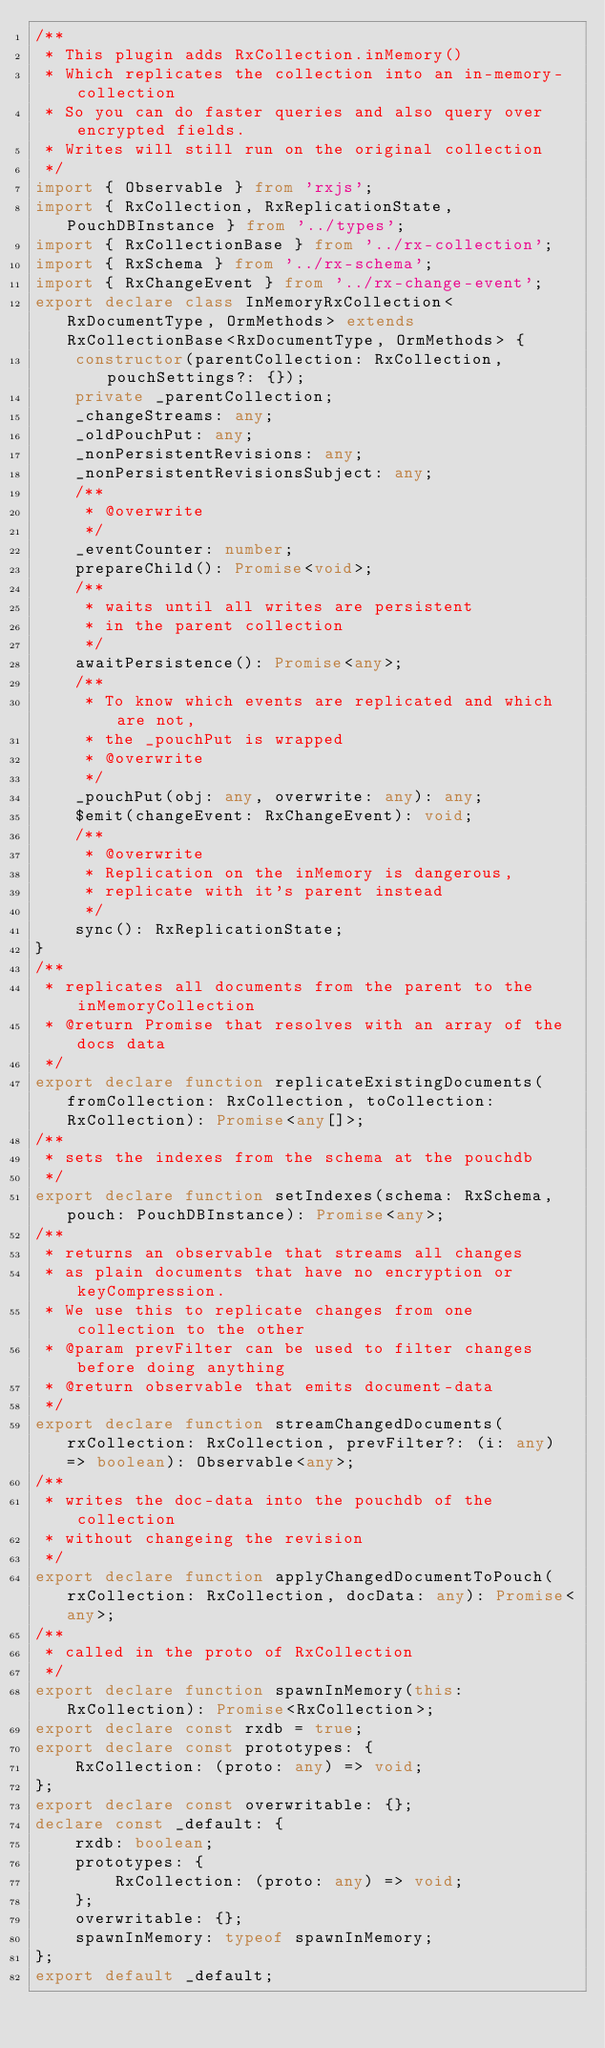Convert code to text. <code><loc_0><loc_0><loc_500><loc_500><_TypeScript_>/**
 * This plugin adds RxCollection.inMemory()
 * Which replicates the collection into an in-memory-collection
 * So you can do faster queries and also query over encrypted fields.
 * Writes will still run on the original collection
 */
import { Observable } from 'rxjs';
import { RxCollection, RxReplicationState, PouchDBInstance } from '../types';
import { RxCollectionBase } from '../rx-collection';
import { RxSchema } from '../rx-schema';
import { RxChangeEvent } from '../rx-change-event';
export declare class InMemoryRxCollection<RxDocumentType, OrmMethods> extends RxCollectionBase<RxDocumentType, OrmMethods> {
    constructor(parentCollection: RxCollection, pouchSettings?: {});
    private _parentCollection;
    _changeStreams: any;
    _oldPouchPut: any;
    _nonPersistentRevisions: any;
    _nonPersistentRevisionsSubject: any;
    /**
     * @overwrite
     */
    _eventCounter: number;
    prepareChild(): Promise<void>;
    /**
     * waits until all writes are persistent
     * in the parent collection
     */
    awaitPersistence(): Promise<any>;
    /**
     * To know which events are replicated and which are not,
     * the _pouchPut is wrapped
     * @overwrite
     */
    _pouchPut(obj: any, overwrite: any): any;
    $emit(changeEvent: RxChangeEvent): void;
    /**
     * @overwrite
     * Replication on the inMemory is dangerous,
     * replicate with it's parent instead
     */
    sync(): RxReplicationState;
}
/**
 * replicates all documents from the parent to the inMemoryCollection
 * @return Promise that resolves with an array of the docs data
 */
export declare function replicateExistingDocuments(fromCollection: RxCollection, toCollection: RxCollection): Promise<any[]>;
/**
 * sets the indexes from the schema at the pouchdb
 */
export declare function setIndexes(schema: RxSchema, pouch: PouchDBInstance): Promise<any>;
/**
 * returns an observable that streams all changes
 * as plain documents that have no encryption or keyCompression.
 * We use this to replicate changes from one collection to the other
 * @param prevFilter can be used to filter changes before doing anything
 * @return observable that emits document-data
 */
export declare function streamChangedDocuments(rxCollection: RxCollection, prevFilter?: (i: any) => boolean): Observable<any>;
/**
 * writes the doc-data into the pouchdb of the collection
 * without changeing the revision
 */
export declare function applyChangedDocumentToPouch(rxCollection: RxCollection, docData: any): Promise<any>;
/**
 * called in the proto of RxCollection
 */
export declare function spawnInMemory(this: RxCollection): Promise<RxCollection>;
export declare const rxdb = true;
export declare const prototypes: {
    RxCollection: (proto: any) => void;
};
export declare const overwritable: {};
declare const _default: {
    rxdb: boolean;
    prototypes: {
        RxCollection: (proto: any) => void;
    };
    overwritable: {};
    spawnInMemory: typeof spawnInMemory;
};
export default _default;
</code> 